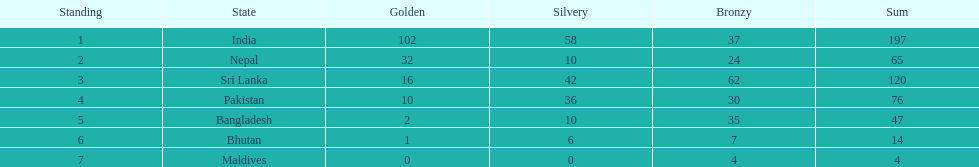Name the first country on the table? India. 